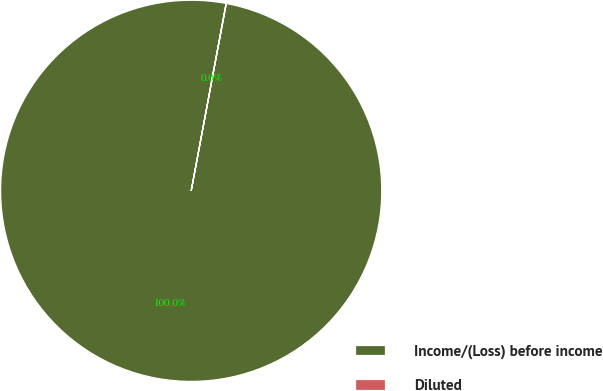<chart> <loc_0><loc_0><loc_500><loc_500><pie_chart><fcel>Income/(Loss) before income<fcel>Diluted<nl><fcel>99.98%<fcel>0.02%<nl></chart> 